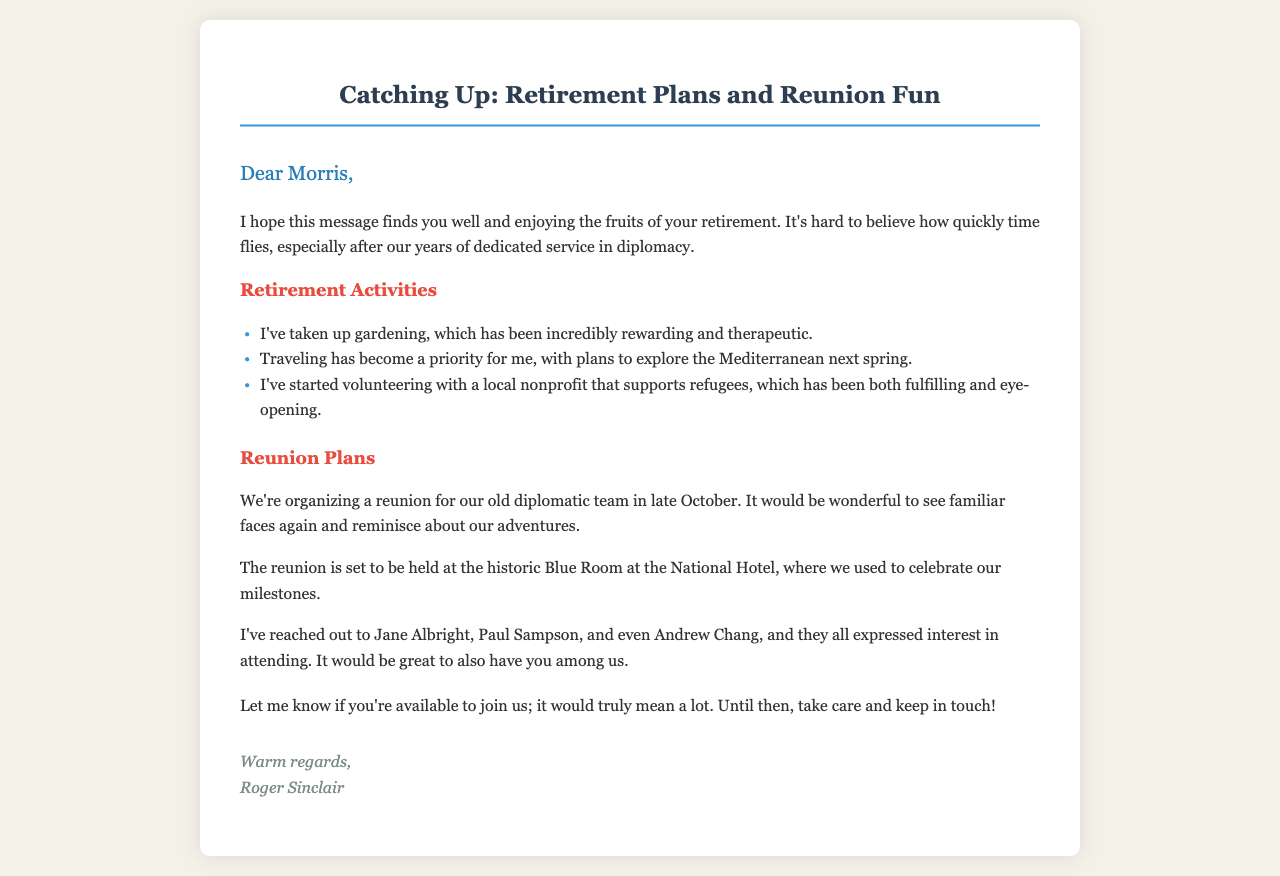what is the name of the sender? The sender of the letter is mentioned at the end as Roger Sinclair.
Answer: Roger Sinclair what is the reunion venue? The venue for the reunion is specified in the document as the historic Blue Room at the National Hotel.
Answer: Blue Room at the National Hotel what month is the reunion scheduled for? The document states that the reunion is organized for late October.
Answer: late October who has shown interest in attending the reunion? Names of those interested include Jane Albright, Paul Sampson, and Andrew Chang, as per the letter.
Answer: Jane Albright, Paul Sampson, Andrew Chang what is one retirement activity the sender has taken up? The letter lists gardening as one of the retirement activities that the sender has started.
Answer: gardening how does the sender describe their volunteering experience? The sender describes their volunteering with a nonprofit as fulfilling and eye-opening.
Answer: fulfilling and eye-opening when does the sender plan to travel next? The sender has plans to travel to the Mediterranean next spring.
Answer: next spring what theme does the greeting of the letter convey? The greeting expresses a desire to know how Morris is doing during his retirement.
Answer: desire to know how Morris is doing 